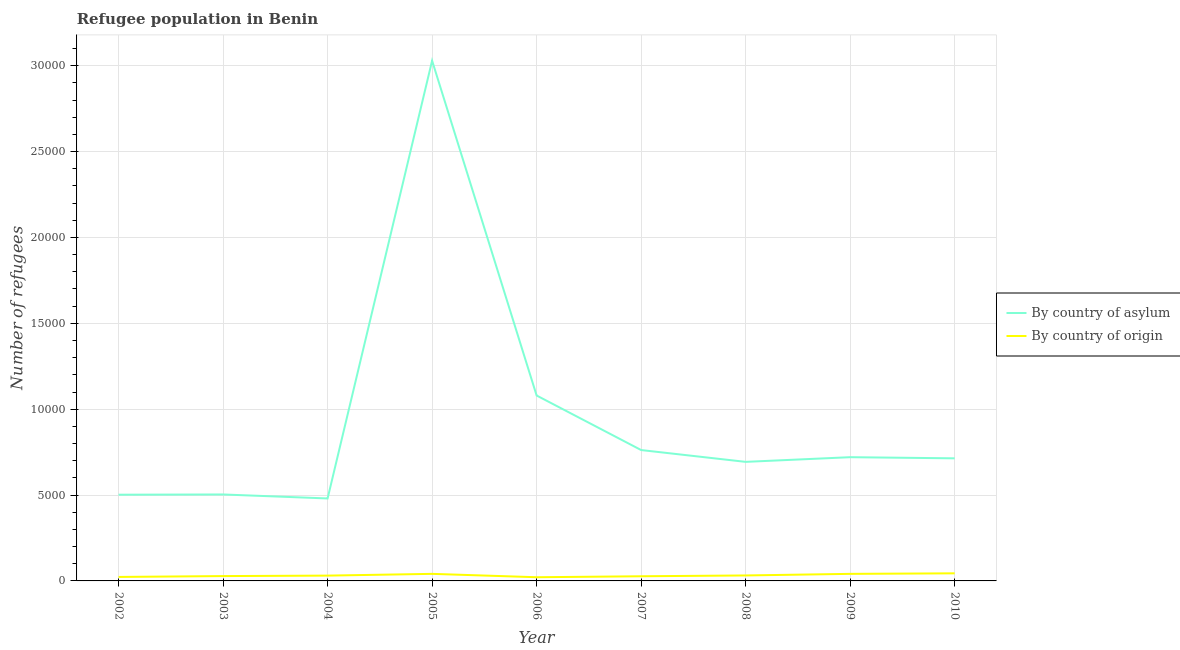How many different coloured lines are there?
Provide a short and direct response. 2. Does the line corresponding to number of refugees by country of asylum intersect with the line corresponding to number of refugees by country of origin?
Your response must be concise. No. Is the number of lines equal to the number of legend labels?
Ensure brevity in your answer.  Yes. What is the number of refugees by country of origin in 2008?
Provide a succinct answer. 318. Across all years, what is the maximum number of refugees by country of origin?
Offer a very short reply. 442. Across all years, what is the minimum number of refugees by country of origin?
Give a very brief answer. 215. In which year was the number of refugees by country of origin minimum?
Give a very brief answer. 2006. What is the total number of refugees by country of asylum in the graph?
Offer a very short reply. 8.48e+04. What is the difference between the number of refugees by country of origin in 2004 and that in 2008?
Offer a very short reply. -9. What is the difference between the number of refugees by country of asylum in 2005 and the number of refugees by country of origin in 2006?
Keep it short and to the point. 3.01e+04. What is the average number of refugees by country of origin per year?
Provide a succinct answer. 321.22. In the year 2002, what is the difference between the number of refugees by country of origin and number of refugees by country of asylum?
Provide a short and direct response. -4789. What is the ratio of the number of refugees by country of origin in 2006 to that in 2009?
Provide a short and direct response. 0.52. What is the difference between the highest and the lowest number of refugees by country of origin?
Your answer should be very brief. 227. In how many years, is the number of refugees by country of asylum greater than the average number of refugees by country of asylum taken over all years?
Your response must be concise. 2. Is the number of refugees by country of origin strictly greater than the number of refugees by country of asylum over the years?
Offer a very short reply. No. Does the graph contain any zero values?
Make the answer very short. No. Does the graph contain grids?
Your answer should be very brief. Yes. Where does the legend appear in the graph?
Your answer should be compact. Center right. How are the legend labels stacked?
Offer a terse response. Vertical. What is the title of the graph?
Your answer should be compact. Refugee population in Benin. What is the label or title of the Y-axis?
Your answer should be compact. Number of refugees. What is the Number of refugees of By country of asylum in 2002?
Your response must be concise. 5021. What is the Number of refugees of By country of origin in 2002?
Keep it short and to the point. 232. What is the Number of refugees in By country of asylum in 2003?
Your response must be concise. 5034. What is the Number of refugees in By country of origin in 2003?
Ensure brevity in your answer.  282. What is the Number of refugees of By country of asylum in 2004?
Offer a very short reply. 4802. What is the Number of refugees of By country of origin in 2004?
Offer a very short reply. 309. What is the Number of refugees of By country of asylum in 2005?
Your response must be concise. 3.03e+04. What is the Number of refugees in By country of origin in 2005?
Provide a succinct answer. 411. What is the Number of refugees in By country of asylum in 2006?
Provide a succinct answer. 1.08e+04. What is the Number of refugees in By country of origin in 2006?
Keep it short and to the point. 215. What is the Number of refugees of By country of asylum in 2007?
Provide a short and direct response. 7621. What is the Number of refugees of By country of origin in 2007?
Give a very brief answer. 271. What is the Number of refugees in By country of asylum in 2008?
Your answer should be very brief. 6933. What is the Number of refugees of By country of origin in 2008?
Offer a very short reply. 318. What is the Number of refugees of By country of asylum in 2009?
Your answer should be very brief. 7205. What is the Number of refugees in By country of origin in 2009?
Provide a short and direct response. 411. What is the Number of refugees of By country of asylum in 2010?
Your answer should be compact. 7139. What is the Number of refugees in By country of origin in 2010?
Provide a short and direct response. 442. Across all years, what is the maximum Number of refugees in By country of asylum?
Provide a succinct answer. 3.03e+04. Across all years, what is the maximum Number of refugees of By country of origin?
Your response must be concise. 442. Across all years, what is the minimum Number of refugees of By country of asylum?
Provide a short and direct response. 4802. Across all years, what is the minimum Number of refugees in By country of origin?
Keep it short and to the point. 215. What is the total Number of refugees of By country of asylum in the graph?
Give a very brief answer. 8.48e+04. What is the total Number of refugees of By country of origin in the graph?
Your response must be concise. 2891. What is the difference between the Number of refugees of By country of asylum in 2002 and that in 2003?
Keep it short and to the point. -13. What is the difference between the Number of refugees of By country of origin in 2002 and that in 2003?
Offer a terse response. -50. What is the difference between the Number of refugees in By country of asylum in 2002 and that in 2004?
Ensure brevity in your answer.  219. What is the difference between the Number of refugees of By country of origin in 2002 and that in 2004?
Your answer should be compact. -77. What is the difference between the Number of refugees of By country of asylum in 2002 and that in 2005?
Ensure brevity in your answer.  -2.53e+04. What is the difference between the Number of refugees in By country of origin in 2002 and that in 2005?
Your response must be concise. -179. What is the difference between the Number of refugees in By country of asylum in 2002 and that in 2006?
Keep it short and to the point. -5776. What is the difference between the Number of refugees of By country of asylum in 2002 and that in 2007?
Offer a very short reply. -2600. What is the difference between the Number of refugees of By country of origin in 2002 and that in 2007?
Offer a terse response. -39. What is the difference between the Number of refugees of By country of asylum in 2002 and that in 2008?
Provide a succinct answer. -1912. What is the difference between the Number of refugees of By country of origin in 2002 and that in 2008?
Ensure brevity in your answer.  -86. What is the difference between the Number of refugees in By country of asylum in 2002 and that in 2009?
Give a very brief answer. -2184. What is the difference between the Number of refugees of By country of origin in 2002 and that in 2009?
Offer a terse response. -179. What is the difference between the Number of refugees in By country of asylum in 2002 and that in 2010?
Your answer should be compact. -2118. What is the difference between the Number of refugees in By country of origin in 2002 and that in 2010?
Make the answer very short. -210. What is the difference between the Number of refugees of By country of asylum in 2003 and that in 2004?
Give a very brief answer. 232. What is the difference between the Number of refugees of By country of origin in 2003 and that in 2004?
Offer a terse response. -27. What is the difference between the Number of refugees of By country of asylum in 2003 and that in 2005?
Offer a terse response. -2.53e+04. What is the difference between the Number of refugees of By country of origin in 2003 and that in 2005?
Your answer should be compact. -129. What is the difference between the Number of refugees of By country of asylum in 2003 and that in 2006?
Ensure brevity in your answer.  -5763. What is the difference between the Number of refugees in By country of origin in 2003 and that in 2006?
Give a very brief answer. 67. What is the difference between the Number of refugees in By country of asylum in 2003 and that in 2007?
Offer a very short reply. -2587. What is the difference between the Number of refugees of By country of asylum in 2003 and that in 2008?
Your response must be concise. -1899. What is the difference between the Number of refugees in By country of origin in 2003 and that in 2008?
Your response must be concise. -36. What is the difference between the Number of refugees of By country of asylum in 2003 and that in 2009?
Provide a succinct answer. -2171. What is the difference between the Number of refugees of By country of origin in 2003 and that in 2009?
Provide a succinct answer. -129. What is the difference between the Number of refugees of By country of asylum in 2003 and that in 2010?
Give a very brief answer. -2105. What is the difference between the Number of refugees in By country of origin in 2003 and that in 2010?
Your answer should be very brief. -160. What is the difference between the Number of refugees in By country of asylum in 2004 and that in 2005?
Your response must be concise. -2.55e+04. What is the difference between the Number of refugees in By country of origin in 2004 and that in 2005?
Make the answer very short. -102. What is the difference between the Number of refugees of By country of asylum in 2004 and that in 2006?
Give a very brief answer. -5995. What is the difference between the Number of refugees of By country of origin in 2004 and that in 2006?
Your response must be concise. 94. What is the difference between the Number of refugees in By country of asylum in 2004 and that in 2007?
Provide a succinct answer. -2819. What is the difference between the Number of refugees of By country of asylum in 2004 and that in 2008?
Your answer should be compact. -2131. What is the difference between the Number of refugees in By country of asylum in 2004 and that in 2009?
Make the answer very short. -2403. What is the difference between the Number of refugees of By country of origin in 2004 and that in 2009?
Make the answer very short. -102. What is the difference between the Number of refugees in By country of asylum in 2004 and that in 2010?
Offer a terse response. -2337. What is the difference between the Number of refugees of By country of origin in 2004 and that in 2010?
Your answer should be compact. -133. What is the difference between the Number of refugees in By country of asylum in 2005 and that in 2006?
Give a very brief answer. 1.95e+04. What is the difference between the Number of refugees of By country of origin in 2005 and that in 2006?
Your answer should be compact. 196. What is the difference between the Number of refugees of By country of asylum in 2005 and that in 2007?
Provide a short and direct response. 2.27e+04. What is the difference between the Number of refugees in By country of origin in 2005 and that in 2007?
Your answer should be very brief. 140. What is the difference between the Number of refugees of By country of asylum in 2005 and that in 2008?
Provide a succinct answer. 2.34e+04. What is the difference between the Number of refugees of By country of origin in 2005 and that in 2008?
Ensure brevity in your answer.  93. What is the difference between the Number of refugees of By country of asylum in 2005 and that in 2009?
Provide a short and direct response. 2.31e+04. What is the difference between the Number of refugees of By country of origin in 2005 and that in 2009?
Ensure brevity in your answer.  0. What is the difference between the Number of refugees in By country of asylum in 2005 and that in 2010?
Make the answer very short. 2.32e+04. What is the difference between the Number of refugees in By country of origin in 2005 and that in 2010?
Provide a succinct answer. -31. What is the difference between the Number of refugees of By country of asylum in 2006 and that in 2007?
Your response must be concise. 3176. What is the difference between the Number of refugees of By country of origin in 2006 and that in 2007?
Your answer should be compact. -56. What is the difference between the Number of refugees in By country of asylum in 2006 and that in 2008?
Your response must be concise. 3864. What is the difference between the Number of refugees of By country of origin in 2006 and that in 2008?
Keep it short and to the point. -103. What is the difference between the Number of refugees of By country of asylum in 2006 and that in 2009?
Offer a very short reply. 3592. What is the difference between the Number of refugees of By country of origin in 2006 and that in 2009?
Provide a succinct answer. -196. What is the difference between the Number of refugees of By country of asylum in 2006 and that in 2010?
Provide a succinct answer. 3658. What is the difference between the Number of refugees in By country of origin in 2006 and that in 2010?
Your answer should be very brief. -227. What is the difference between the Number of refugees of By country of asylum in 2007 and that in 2008?
Ensure brevity in your answer.  688. What is the difference between the Number of refugees in By country of origin in 2007 and that in 2008?
Make the answer very short. -47. What is the difference between the Number of refugees of By country of asylum in 2007 and that in 2009?
Give a very brief answer. 416. What is the difference between the Number of refugees of By country of origin in 2007 and that in 2009?
Provide a succinct answer. -140. What is the difference between the Number of refugees of By country of asylum in 2007 and that in 2010?
Provide a succinct answer. 482. What is the difference between the Number of refugees of By country of origin in 2007 and that in 2010?
Your response must be concise. -171. What is the difference between the Number of refugees of By country of asylum in 2008 and that in 2009?
Provide a succinct answer. -272. What is the difference between the Number of refugees in By country of origin in 2008 and that in 2009?
Your answer should be compact. -93. What is the difference between the Number of refugees of By country of asylum in 2008 and that in 2010?
Offer a very short reply. -206. What is the difference between the Number of refugees in By country of origin in 2008 and that in 2010?
Provide a succinct answer. -124. What is the difference between the Number of refugees of By country of asylum in 2009 and that in 2010?
Your answer should be compact. 66. What is the difference between the Number of refugees in By country of origin in 2009 and that in 2010?
Your answer should be very brief. -31. What is the difference between the Number of refugees of By country of asylum in 2002 and the Number of refugees of By country of origin in 2003?
Offer a terse response. 4739. What is the difference between the Number of refugees of By country of asylum in 2002 and the Number of refugees of By country of origin in 2004?
Provide a succinct answer. 4712. What is the difference between the Number of refugees in By country of asylum in 2002 and the Number of refugees in By country of origin in 2005?
Make the answer very short. 4610. What is the difference between the Number of refugees in By country of asylum in 2002 and the Number of refugees in By country of origin in 2006?
Offer a very short reply. 4806. What is the difference between the Number of refugees of By country of asylum in 2002 and the Number of refugees of By country of origin in 2007?
Ensure brevity in your answer.  4750. What is the difference between the Number of refugees in By country of asylum in 2002 and the Number of refugees in By country of origin in 2008?
Provide a succinct answer. 4703. What is the difference between the Number of refugees of By country of asylum in 2002 and the Number of refugees of By country of origin in 2009?
Offer a very short reply. 4610. What is the difference between the Number of refugees of By country of asylum in 2002 and the Number of refugees of By country of origin in 2010?
Your answer should be compact. 4579. What is the difference between the Number of refugees in By country of asylum in 2003 and the Number of refugees in By country of origin in 2004?
Give a very brief answer. 4725. What is the difference between the Number of refugees of By country of asylum in 2003 and the Number of refugees of By country of origin in 2005?
Make the answer very short. 4623. What is the difference between the Number of refugees in By country of asylum in 2003 and the Number of refugees in By country of origin in 2006?
Keep it short and to the point. 4819. What is the difference between the Number of refugees of By country of asylum in 2003 and the Number of refugees of By country of origin in 2007?
Your response must be concise. 4763. What is the difference between the Number of refugees in By country of asylum in 2003 and the Number of refugees in By country of origin in 2008?
Your answer should be compact. 4716. What is the difference between the Number of refugees in By country of asylum in 2003 and the Number of refugees in By country of origin in 2009?
Make the answer very short. 4623. What is the difference between the Number of refugees of By country of asylum in 2003 and the Number of refugees of By country of origin in 2010?
Offer a very short reply. 4592. What is the difference between the Number of refugees of By country of asylum in 2004 and the Number of refugees of By country of origin in 2005?
Provide a succinct answer. 4391. What is the difference between the Number of refugees of By country of asylum in 2004 and the Number of refugees of By country of origin in 2006?
Your response must be concise. 4587. What is the difference between the Number of refugees in By country of asylum in 2004 and the Number of refugees in By country of origin in 2007?
Provide a succinct answer. 4531. What is the difference between the Number of refugees in By country of asylum in 2004 and the Number of refugees in By country of origin in 2008?
Provide a short and direct response. 4484. What is the difference between the Number of refugees of By country of asylum in 2004 and the Number of refugees of By country of origin in 2009?
Your answer should be very brief. 4391. What is the difference between the Number of refugees of By country of asylum in 2004 and the Number of refugees of By country of origin in 2010?
Ensure brevity in your answer.  4360. What is the difference between the Number of refugees of By country of asylum in 2005 and the Number of refugees of By country of origin in 2006?
Make the answer very short. 3.01e+04. What is the difference between the Number of refugees of By country of asylum in 2005 and the Number of refugees of By country of origin in 2007?
Make the answer very short. 3.00e+04. What is the difference between the Number of refugees of By country of asylum in 2005 and the Number of refugees of By country of origin in 2008?
Your response must be concise. 3.00e+04. What is the difference between the Number of refugees of By country of asylum in 2005 and the Number of refugees of By country of origin in 2009?
Offer a very short reply. 2.99e+04. What is the difference between the Number of refugees in By country of asylum in 2005 and the Number of refugees in By country of origin in 2010?
Your answer should be very brief. 2.99e+04. What is the difference between the Number of refugees of By country of asylum in 2006 and the Number of refugees of By country of origin in 2007?
Ensure brevity in your answer.  1.05e+04. What is the difference between the Number of refugees of By country of asylum in 2006 and the Number of refugees of By country of origin in 2008?
Offer a very short reply. 1.05e+04. What is the difference between the Number of refugees of By country of asylum in 2006 and the Number of refugees of By country of origin in 2009?
Keep it short and to the point. 1.04e+04. What is the difference between the Number of refugees in By country of asylum in 2006 and the Number of refugees in By country of origin in 2010?
Provide a succinct answer. 1.04e+04. What is the difference between the Number of refugees in By country of asylum in 2007 and the Number of refugees in By country of origin in 2008?
Offer a terse response. 7303. What is the difference between the Number of refugees of By country of asylum in 2007 and the Number of refugees of By country of origin in 2009?
Your answer should be very brief. 7210. What is the difference between the Number of refugees of By country of asylum in 2007 and the Number of refugees of By country of origin in 2010?
Provide a short and direct response. 7179. What is the difference between the Number of refugees in By country of asylum in 2008 and the Number of refugees in By country of origin in 2009?
Provide a succinct answer. 6522. What is the difference between the Number of refugees of By country of asylum in 2008 and the Number of refugees of By country of origin in 2010?
Offer a terse response. 6491. What is the difference between the Number of refugees in By country of asylum in 2009 and the Number of refugees in By country of origin in 2010?
Provide a succinct answer. 6763. What is the average Number of refugees in By country of asylum per year?
Your response must be concise. 9427.33. What is the average Number of refugees in By country of origin per year?
Provide a short and direct response. 321.22. In the year 2002, what is the difference between the Number of refugees of By country of asylum and Number of refugees of By country of origin?
Ensure brevity in your answer.  4789. In the year 2003, what is the difference between the Number of refugees in By country of asylum and Number of refugees in By country of origin?
Provide a short and direct response. 4752. In the year 2004, what is the difference between the Number of refugees in By country of asylum and Number of refugees in By country of origin?
Your answer should be very brief. 4493. In the year 2005, what is the difference between the Number of refugees of By country of asylum and Number of refugees of By country of origin?
Give a very brief answer. 2.99e+04. In the year 2006, what is the difference between the Number of refugees in By country of asylum and Number of refugees in By country of origin?
Make the answer very short. 1.06e+04. In the year 2007, what is the difference between the Number of refugees of By country of asylum and Number of refugees of By country of origin?
Your response must be concise. 7350. In the year 2008, what is the difference between the Number of refugees of By country of asylum and Number of refugees of By country of origin?
Provide a succinct answer. 6615. In the year 2009, what is the difference between the Number of refugees in By country of asylum and Number of refugees in By country of origin?
Provide a succinct answer. 6794. In the year 2010, what is the difference between the Number of refugees in By country of asylum and Number of refugees in By country of origin?
Provide a succinct answer. 6697. What is the ratio of the Number of refugees in By country of asylum in 2002 to that in 2003?
Your answer should be compact. 1. What is the ratio of the Number of refugees of By country of origin in 2002 to that in 2003?
Offer a very short reply. 0.82. What is the ratio of the Number of refugees in By country of asylum in 2002 to that in 2004?
Provide a succinct answer. 1.05. What is the ratio of the Number of refugees of By country of origin in 2002 to that in 2004?
Give a very brief answer. 0.75. What is the ratio of the Number of refugees of By country of asylum in 2002 to that in 2005?
Offer a terse response. 0.17. What is the ratio of the Number of refugees of By country of origin in 2002 to that in 2005?
Your response must be concise. 0.56. What is the ratio of the Number of refugees of By country of asylum in 2002 to that in 2006?
Keep it short and to the point. 0.47. What is the ratio of the Number of refugees in By country of origin in 2002 to that in 2006?
Make the answer very short. 1.08. What is the ratio of the Number of refugees of By country of asylum in 2002 to that in 2007?
Give a very brief answer. 0.66. What is the ratio of the Number of refugees of By country of origin in 2002 to that in 2007?
Ensure brevity in your answer.  0.86. What is the ratio of the Number of refugees in By country of asylum in 2002 to that in 2008?
Make the answer very short. 0.72. What is the ratio of the Number of refugees of By country of origin in 2002 to that in 2008?
Provide a succinct answer. 0.73. What is the ratio of the Number of refugees in By country of asylum in 2002 to that in 2009?
Offer a terse response. 0.7. What is the ratio of the Number of refugees in By country of origin in 2002 to that in 2009?
Your answer should be very brief. 0.56. What is the ratio of the Number of refugees in By country of asylum in 2002 to that in 2010?
Provide a succinct answer. 0.7. What is the ratio of the Number of refugees in By country of origin in 2002 to that in 2010?
Your response must be concise. 0.52. What is the ratio of the Number of refugees of By country of asylum in 2003 to that in 2004?
Your answer should be very brief. 1.05. What is the ratio of the Number of refugees of By country of origin in 2003 to that in 2004?
Provide a short and direct response. 0.91. What is the ratio of the Number of refugees of By country of asylum in 2003 to that in 2005?
Make the answer very short. 0.17. What is the ratio of the Number of refugees in By country of origin in 2003 to that in 2005?
Ensure brevity in your answer.  0.69. What is the ratio of the Number of refugees in By country of asylum in 2003 to that in 2006?
Give a very brief answer. 0.47. What is the ratio of the Number of refugees of By country of origin in 2003 to that in 2006?
Your answer should be very brief. 1.31. What is the ratio of the Number of refugees of By country of asylum in 2003 to that in 2007?
Your answer should be compact. 0.66. What is the ratio of the Number of refugees in By country of origin in 2003 to that in 2007?
Provide a short and direct response. 1.04. What is the ratio of the Number of refugees of By country of asylum in 2003 to that in 2008?
Offer a terse response. 0.73. What is the ratio of the Number of refugees of By country of origin in 2003 to that in 2008?
Your answer should be compact. 0.89. What is the ratio of the Number of refugees in By country of asylum in 2003 to that in 2009?
Your answer should be compact. 0.7. What is the ratio of the Number of refugees of By country of origin in 2003 to that in 2009?
Offer a very short reply. 0.69. What is the ratio of the Number of refugees in By country of asylum in 2003 to that in 2010?
Make the answer very short. 0.71. What is the ratio of the Number of refugees in By country of origin in 2003 to that in 2010?
Your answer should be very brief. 0.64. What is the ratio of the Number of refugees in By country of asylum in 2004 to that in 2005?
Keep it short and to the point. 0.16. What is the ratio of the Number of refugees in By country of origin in 2004 to that in 2005?
Provide a succinct answer. 0.75. What is the ratio of the Number of refugees of By country of asylum in 2004 to that in 2006?
Offer a terse response. 0.44. What is the ratio of the Number of refugees of By country of origin in 2004 to that in 2006?
Keep it short and to the point. 1.44. What is the ratio of the Number of refugees in By country of asylum in 2004 to that in 2007?
Ensure brevity in your answer.  0.63. What is the ratio of the Number of refugees in By country of origin in 2004 to that in 2007?
Your response must be concise. 1.14. What is the ratio of the Number of refugees in By country of asylum in 2004 to that in 2008?
Make the answer very short. 0.69. What is the ratio of the Number of refugees of By country of origin in 2004 to that in 2008?
Your response must be concise. 0.97. What is the ratio of the Number of refugees of By country of asylum in 2004 to that in 2009?
Ensure brevity in your answer.  0.67. What is the ratio of the Number of refugees in By country of origin in 2004 to that in 2009?
Ensure brevity in your answer.  0.75. What is the ratio of the Number of refugees of By country of asylum in 2004 to that in 2010?
Your answer should be compact. 0.67. What is the ratio of the Number of refugees of By country of origin in 2004 to that in 2010?
Offer a terse response. 0.7. What is the ratio of the Number of refugees of By country of asylum in 2005 to that in 2006?
Your answer should be compact. 2.81. What is the ratio of the Number of refugees in By country of origin in 2005 to that in 2006?
Offer a very short reply. 1.91. What is the ratio of the Number of refugees in By country of asylum in 2005 to that in 2007?
Your answer should be compact. 3.98. What is the ratio of the Number of refugees in By country of origin in 2005 to that in 2007?
Make the answer very short. 1.52. What is the ratio of the Number of refugees in By country of asylum in 2005 to that in 2008?
Give a very brief answer. 4.37. What is the ratio of the Number of refugees in By country of origin in 2005 to that in 2008?
Provide a short and direct response. 1.29. What is the ratio of the Number of refugees of By country of asylum in 2005 to that in 2009?
Offer a very short reply. 4.2. What is the ratio of the Number of refugees in By country of origin in 2005 to that in 2009?
Keep it short and to the point. 1. What is the ratio of the Number of refugees in By country of asylum in 2005 to that in 2010?
Ensure brevity in your answer.  4.24. What is the ratio of the Number of refugees in By country of origin in 2005 to that in 2010?
Provide a short and direct response. 0.93. What is the ratio of the Number of refugees in By country of asylum in 2006 to that in 2007?
Your answer should be compact. 1.42. What is the ratio of the Number of refugees of By country of origin in 2006 to that in 2007?
Provide a succinct answer. 0.79. What is the ratio of the Number of refugees of By country of asylum in 2006 to that in 2008?
Provide a short and direct response. 1.56. What is the ratio of the Number of refugees in By country of origin in 2006 to that in 2008?
Your response must be concise. 0.68. What is the ratio of the Number of refugees of By country of asylum in 2006 to that in 2009?
Offer a very short reply. 1.5. What is the ratio of the Number of refugees in By country of origin in 2006 to that in 2009?
Give a very brief answer. 0.52. What is the ratio of the Number of refugees of By country of asylum in 2006 to that in 2010?
Ensure brevity in your answer.  1.51. What is the ratio of the Number of refugees of By country of origin in 2006 to that in 2010?
Give a very brief answer. 0.49. What is the ratio of the Number of refugees of By country of asylum in 2007 to that in 2008?
Your answer should be compact. 1.1. What is the ratio of the Number of refugees of By country of origin in 2007 to that in 2008?
Make the answer very short. 0.85. What is the ratio of the Number of refugees in By country of asylum in 2007 to that in 2009?
Make the answer very short. 1.06. What is the ratio of the Number of refugees in By country of origin in 2007 to that in 2009?
Make the answer very short. 0.66. What is the ratio of the Number of refugees in By country of asylum in 2007 to that in 2010?
Your answer should be compact. 1.07. What is the ratio of the Number of refugees of By country of origin in 2007 to that in 2010?
Offer a very short reply. 0.61. What is the ratio of the Number of refugees in By country of asylum in 2008 to that in 2009?
Offer a terse response. 0.96. What is the ratio of the Number of refugees of By country of origin in 2008 to that in 2009?
Offer a very short reply. 0.77. What is the ratio of the Number of refugees of By country of asylum in 2008 to that in 2010?
Offer a very short reply. 0.97. What is the ratio of the Number of refugees of By country of origin in 2008 to that in 2010?
Provide a succinct answer. 0.72. What is the ratio of the Number of refugees of By country of asylum in 2009 to that in 2010?
Offer a terse response. 1.01. What is the ratio of the Number of refugees in By country of origin in 2009 to that in 2010?
Make the answer very short. 0.93. What is the difference between the highest and the second highest Number of refugees of By country of asylum?
Give a very brief answer. 1.95e+04. What is the difference between the highest and the lowest Number of refugees in By country of asylum?
Keep it short and to the point. 2.55e+04. What is the difference between the highest and the lowest Number of refugees in By country of origin?
Your answer should be compact. 227. 